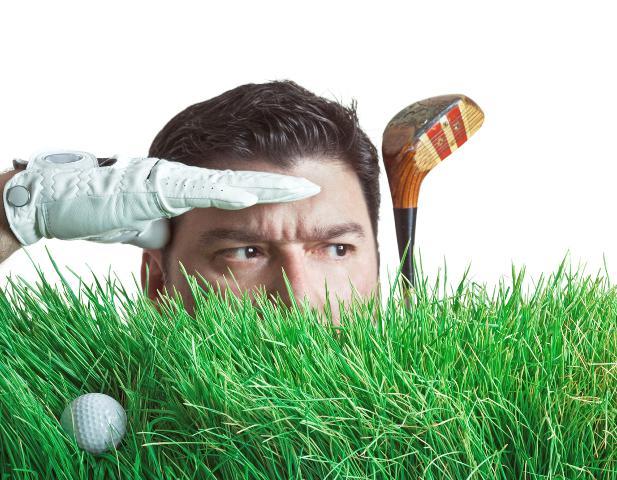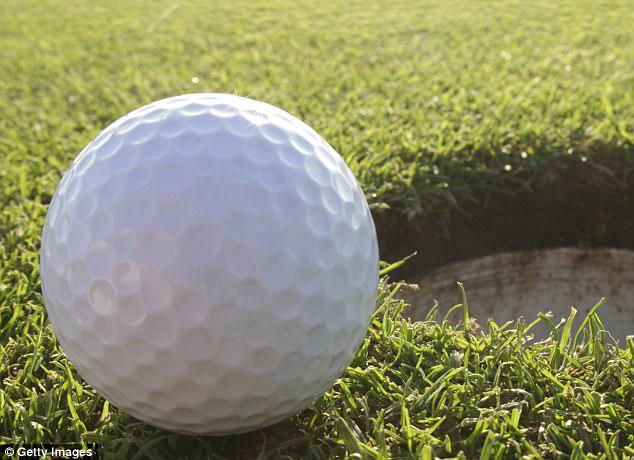The first image is the image on the left, the second image is the image on the right. Analyze the images presented: Is the assertion "There are two balls sitting directly on the grass." valid? Answer yes or no. Yes. The first image is the image on the left, the second image is the image on the right. For the images shown, is this caption "Each image contains only one actual, round golf ball." true? Answer yes or no. Yes. 